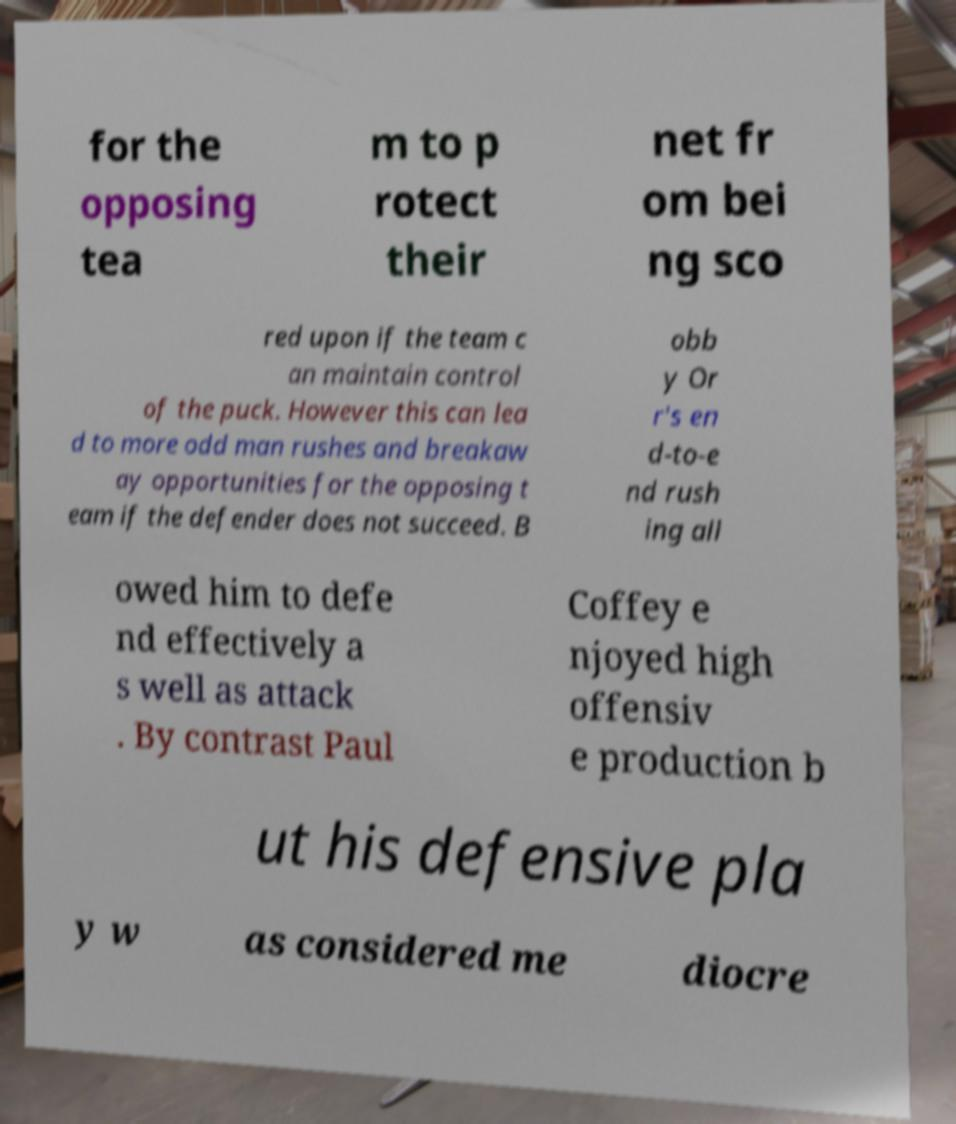Can you read and provide the text displayed in the image?This photo seems to have some interesting text. Can you extract and type it out for me? for the opposing tea m to p rotect their net fr om bei ng sco red upon if the team c an maintain control of the puck. However this can lea d to more odd man rushes and breakaw ay opportunities for the opposing t eam if the defender does not succeed. B obb y Or r's en d-to-e nd rush ing all owed him to defe nd effectively a s well as attack . By contrast Paul Coffey e njoyed high offensiv e production b ut his defensive pla y w as considered me diocre 